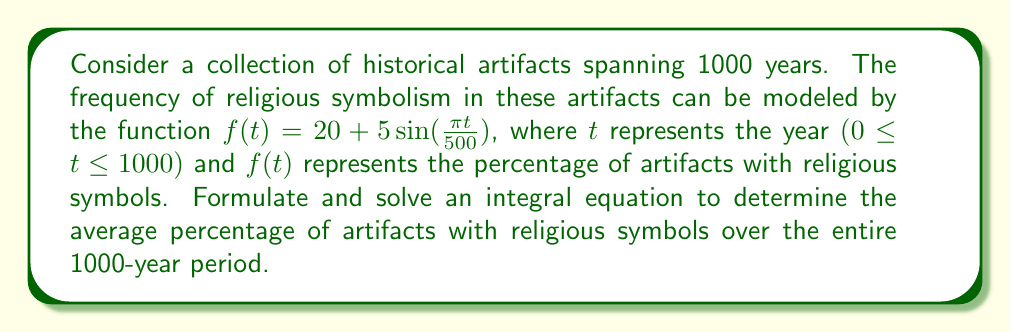Can you solve this math problem? To solve this problem, we need to follow these steps:

1) The average percentage of artifacts with religious symbols can be calculated using the definite integral of the function $f(t)$ over the given time period, divided by the length of the time period.

2) We can formulate this as an integral equation:

   $$\frac{1}{1000} \int_0^{1000} f(t) dt = A$$

   where $A$ represents the average percentage we're looking for.

3) Substitute the given function into the equation:

   $$\frac{1}{1000} \int_0^{1000} (20 + 5\sin(\frac{\pi t}{500})) dt = A$$

4) Solve the integral:
   
   $$A = \frac{1}{1000} [20t - \frac{2500}{\pi} \cos(\frac{\pi t}{500})]_0^{1000}$$

5) Evaluate the integral:

   $$A = \frac{1}{1000} [(20 \cdot 1000 - \frac{2500}{\pi} \cos(2\pi)) - (0 - \frac{2500}{\pi} \cos(0))]$$

6) Simplify:

   $$A = 20 - \frac{2500}{1000\pi} (\cos(2\pi) - 1)$$

7) Since $\cos(2\pi) = 1$, this simplifies to:

   $$A = 20$$

Therefore, the average percentage of artifacts with religious symbols over the 1000-year period is 20%.
Answer: 20% 